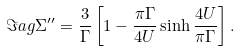<formula> <loc_0><loc_0><loc_500><loc_500>\Im a g \Sigma ^ { \prime \prime } = \frac { 3 } { \Gamma } \left [ 1 - \frac { \pi \Gamma } { 4 U } \sinh \frac { 4 U } { \pi \Gamma } \right ] .</formula> 